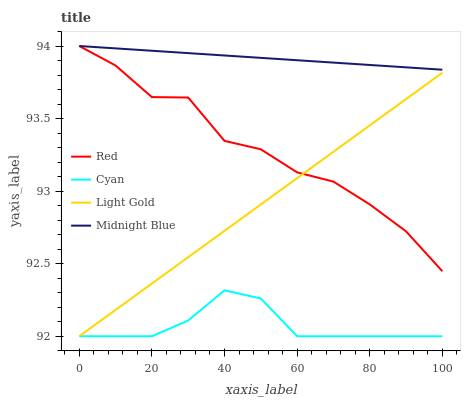Does Light Gold have the minimum area under the curve?
Answer yes or no. No. Does Light Gold have the maximum area under the curve?
Answer yes or no. No. Is Light Gold the smoothest?
Answer yes or no. No. Is Light Gold the roughest?
Answer yes or no. No. Does Midnight Blue have the lowest value?
Answer yes or no. No. Does Light Gold have the highest value?
Answer yes or no. No. Is Light Gold less than Midnight Blue?
Answer yes or no. Yes. Is Red greater than Cyan?
Answer yes or no. Yes. Does Light Gold intersect Midnight Blue?
Answer yes or no. No. 